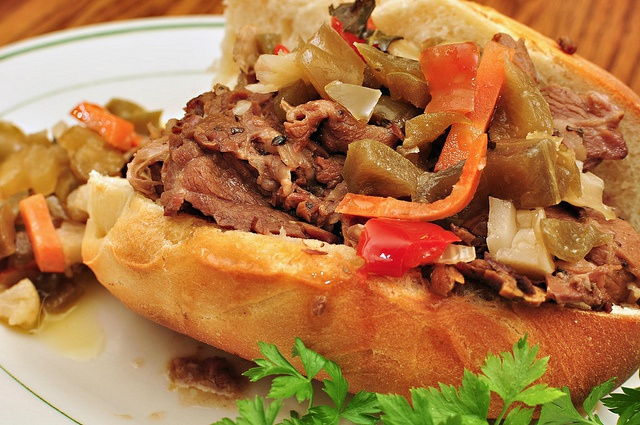Describe the objects in this image and their specific colors. I can see sandwich in maroon, brown, tan, and red tones, carrot in maroon, red, and orange tones, carrot in maroon, orange, red, and brown tones, and carrot in maroon, red, orange, and salmon tones in this image. 